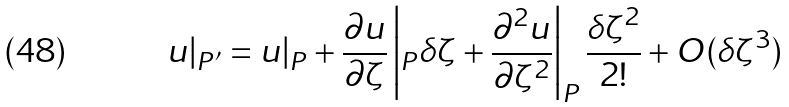<formula> <loc_0><loc_0><loc_500><loc_500>u | _ { P ^ { \prime } } = u | _ { P } + \Big . \frac { \partial u } { \partial { \zeta } } \left | _ { P } \delta \zeta + \Big . \frac { \partial ^ { 2 } u } { \partial { \zeta } ^ { 2 } } \right | _ { P } \frac { { \delta \zeta } ^ { 2 } } { 2 ! } + O ( \delta \zeta ^ { 3 } )</formula> 